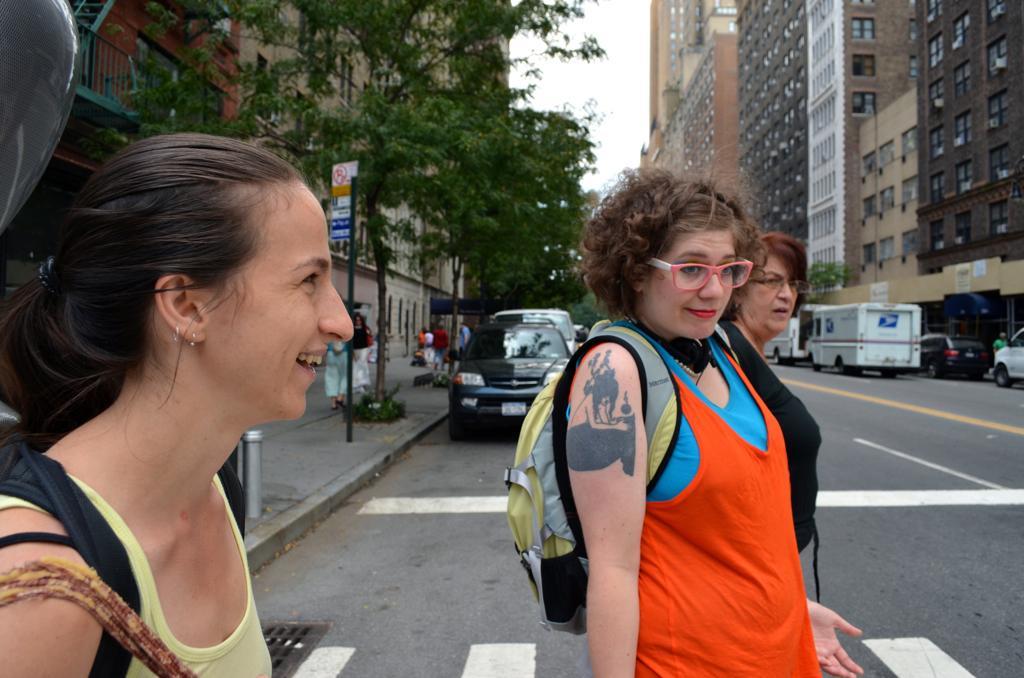Describe this image in one or two sentences. In this picture we can see three women carrying bags and smiling and standing on the road, vehicles, trees, signboards, buildings with windows and some people walking on a footpath and in the background we can see the sky. 